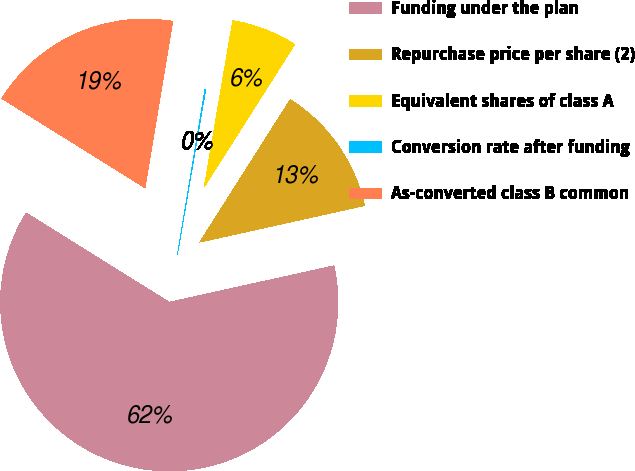Convert chart. <chart><loc_0><loc_0><loc_500><loc_500><pie_chart><fcel>Funding under the plan<fcel>Repurchase price per share (2)<fcel>Equivalent shares of class A<fcel>Conversion rate after funding<fcel>As-converted class B common<nl><fcel>62.35%<fcel>12.53%<fcel>6.3%<fcel>0.07%<fcel>18.75%<nl></chart> 